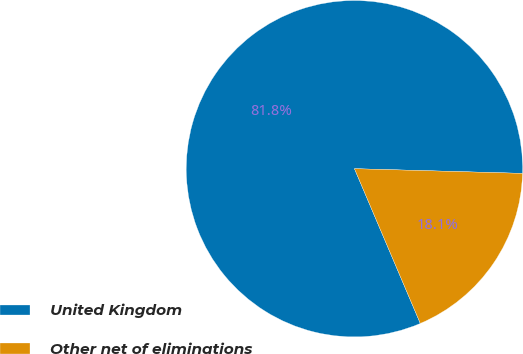<chart> <loc_0><loc_0><loc_500><loc_500><pie_chart><fcel>United Kingdom<fcel>Other net of eliminations<nl><fcel>81.85%<fcel>18.15%<nl></chart> 